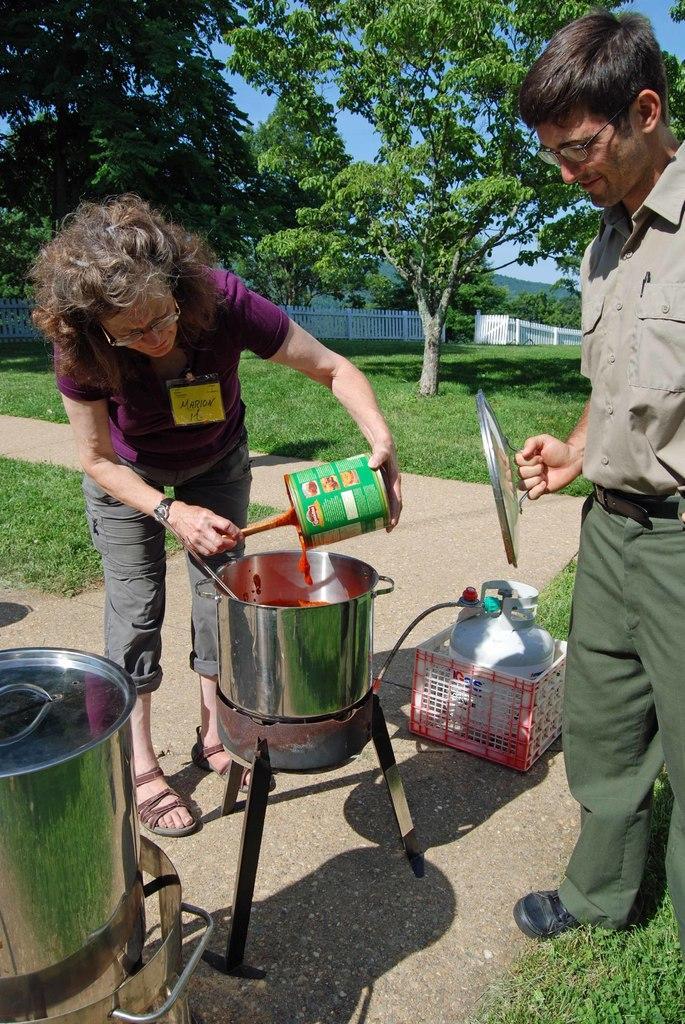Describe this image in one or two sentences. In this picture I can see a man and a woman are standing. Here I can see these people are holding some objects in the hand. In the background I can see trees, white color fence and the grass. Here I can see some objects on the ground. 